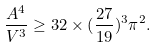Convert formula to latex. <formula><loc_0><loc_0><loc_500><loc_500>\frac { A ^ { 4 } } { V ^ { 3 } } \geq 3 2 \times ( \frac { 2 7 } { 1 9 } ) ^ { 3 } \pi ^ { 2 } .</formula> 